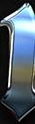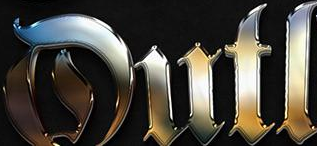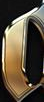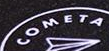What words are shown in these images in order, separated by a semicolon? #; Dutl; #; COMETA 